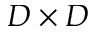<formula> <loc_0><loc_0><loc_500><loc_500>D \times D</formula> 